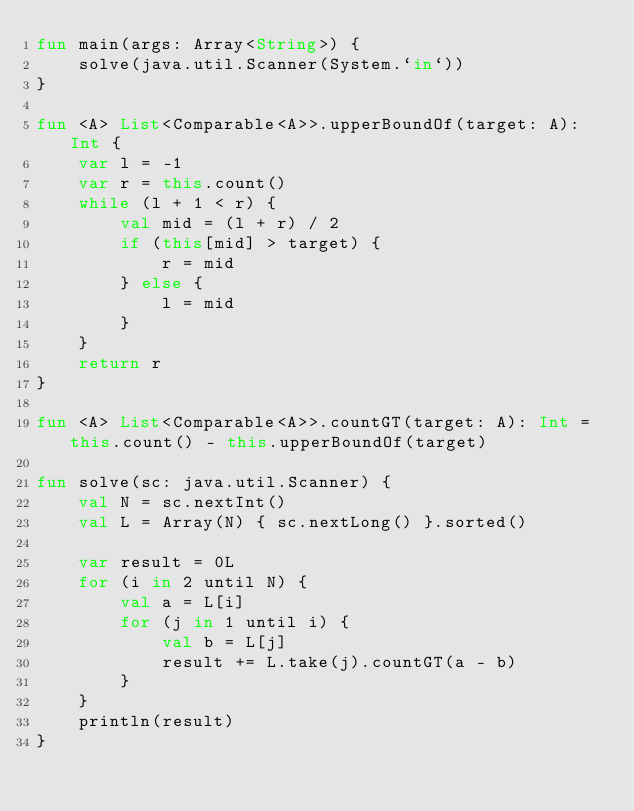Convert code to text. <code><loc_0><loc_0><loc_500><loc_500><_Kotlin_>fun main(args: Array<String>) {
    solve(java.util.Scanner(System.`in`))
}

fun <A> List<Comparable<A>>.upperBoundOf(target: A): Int {
    var l = -1
    var r = this.count()
    while (l + 1 < r) {
        val mid = (l + r) / 2
        if (this[mid] > target) {
            r = mid
        } else {
            l = mid
        }
    }
    return r
}

fun <A> List<Comparable<A>>.countGT(target: A): Int = this.count() - this.upperBoundOf(target)

fun solve(sc: java.util.Scanner) {
    val N = sc.nextInt()
    val L = Array(N) { sc.nextLong() }.sorted()

    var result = 0L
    for (i in 2 until N) {
        val a = L[i]
        for (j in 1 until i) {
            val b = L[j]
            result += L.take(j).countGT(a - b)
        }
    }
    println(result)
}
</code> 